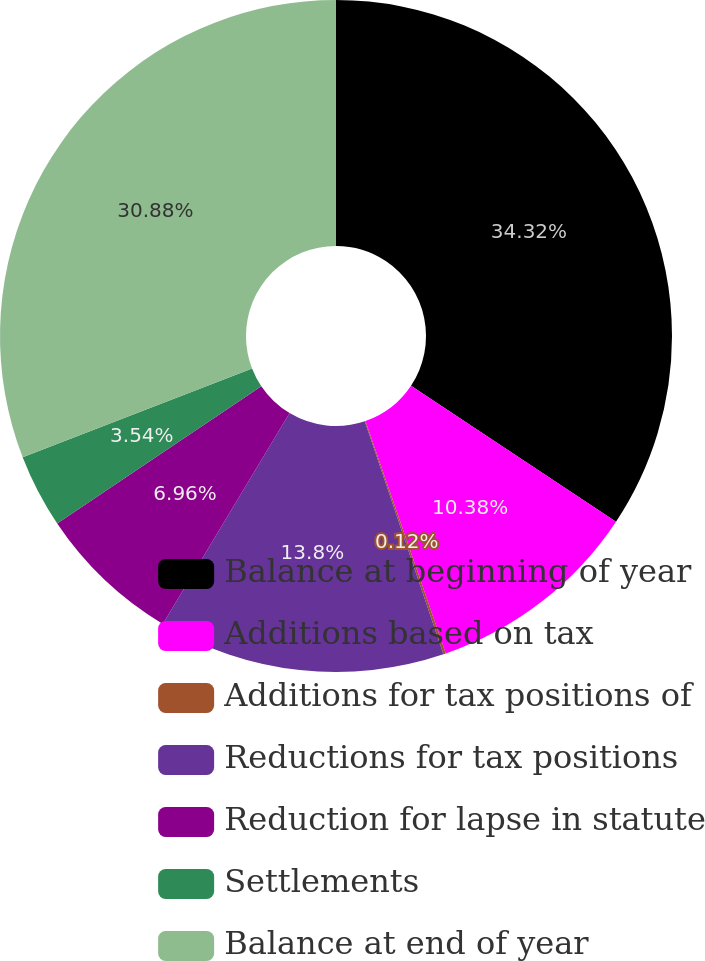Convert chart to OTSL. <chart><loc_0><loc_0><loc_500><loc_500><pie_chart><fcel>Balance at beginning of year<fcel>Additions based on tax<fcel>Additions for tax positions of<fcel>Reductions for tax positions<fcel>Reduction for lapse in statute<fcel>Settlements<fcel>Balance at end of year<nl><fcel>34.32%<fcel>10.38%<fcel>0.12%<fcel>13.8%<fcel>6.96%<fcel>3.54%<fcel>30.88%<nl></chart> 